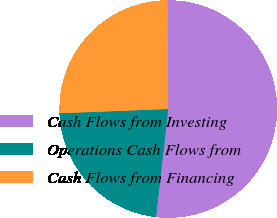<chart> <loc_0><loc_0><loc_500><loc_500><pie_chart><fcel>Cash Flows from Investing<fcel>Operations Cash Flows from<fcel>Cash Flows from Financing<nl><fcel>51.9%<fcel>22.58%<fcel>25.52%<nl></chart> 